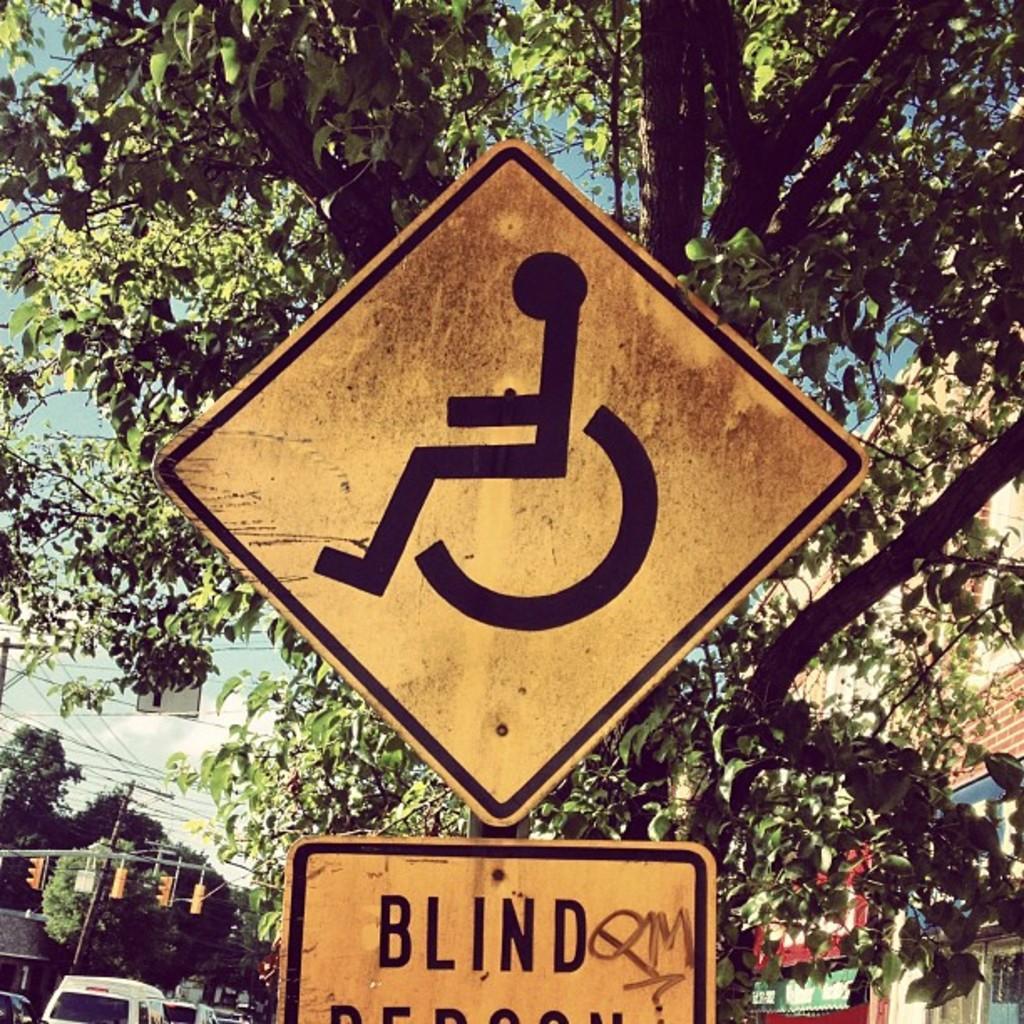Please provide a concise description of this image. In the middle of the image we can see a pole and sign board. Behind the pole we can see some trees, poles and buildings. In the bottom left corner of the image we can see some vehicles. At the top of the image we can see some clouds in the sky. 